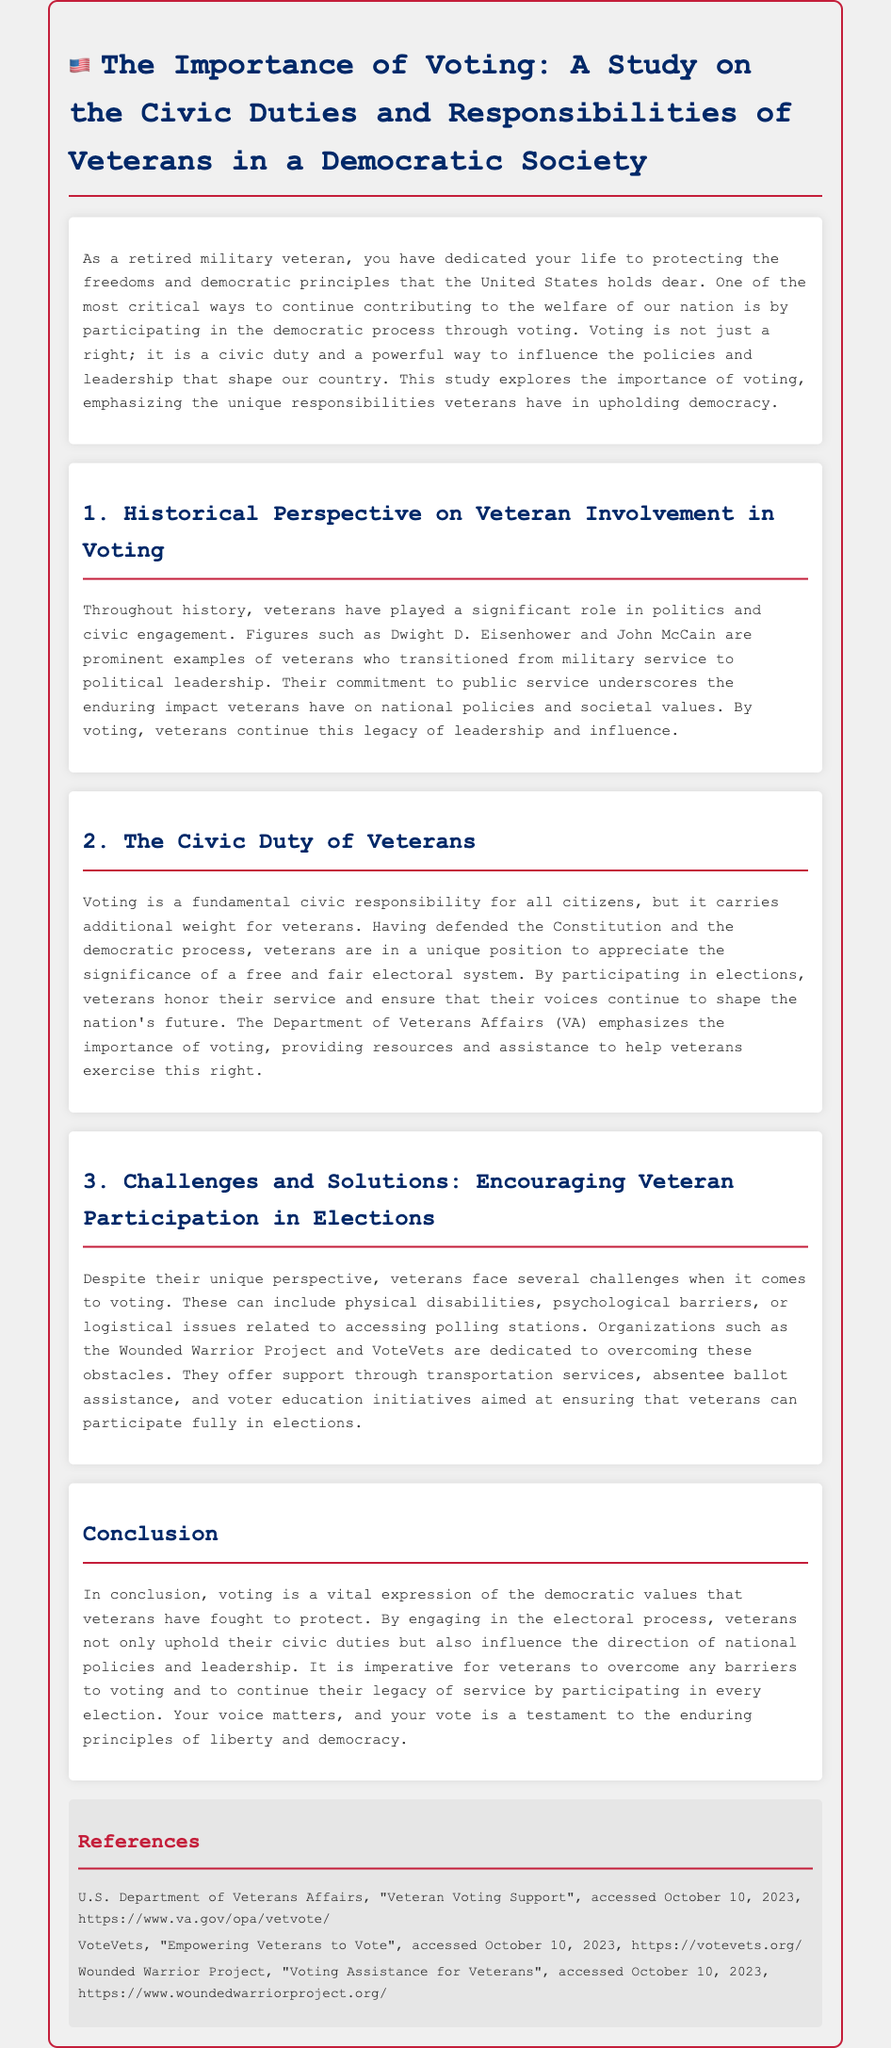What is the title of the study? The title is presented at the top of the document as the main heading.
Answer: The Importance of Voting: A Study on the Civic Duties and Responsibilities of Veterans in a Democratic Society Who is mentioned as a prominent example of a veteran in politics? The document references notable figures who were veterans, illustrating their roles in political leadership.
Answer: John McCain What organization provides resources and assistance for veterans voting? This organization emphasizes the importance of voting for veterans and offers support.
Answer: Department of Veterans Affairs What is one challenge veterans face when voting? The document lists specific issues that hinder veterans from participating in elections.
Answer: Physical disabilities Which organization focuses on empowering veterans to vote? This organization is specifically mentioned in the document for its role in supporting veteran participation in elections.
Answer: VoteVets What is the primary civic responsibility discussed in the study? The document emphasizes a key responsibility of all citizens, particularly veterans.
Answer: Voting What kind of support does the Wounded Warrior Project offer? The document outlines the types of assistance provided by this organization to help veterans vote.
Answer: Voting assistance How does participating in elections honor a veteran's service? The document explains the significance of veterans' contributions through their actions in the democratic process.
Answer: It ensures their voices continue to shape the nation's future 